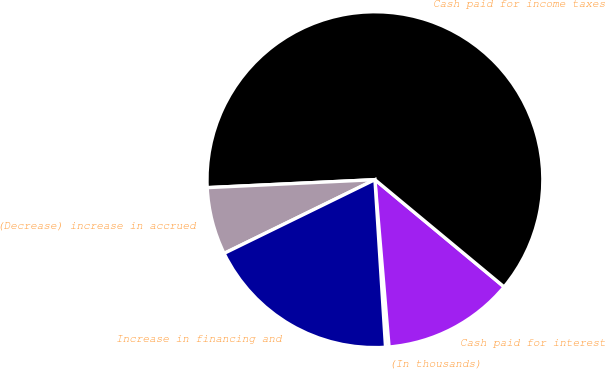Convert chart. <chart><loc_0><loc_0><loc_500><loc_500><pie_chart><fcel>(In thousands)<fcel>Cash paid for interest<fcel>Cash paid for income taxes<fcel>(Decrease) increase in accrued<fcel>Increase in financing and<nl><fcel>0.34%<fcel>12.63%<fcel>61.79%<fcel>6.48%<fcel>18.77%<nl></chart> 